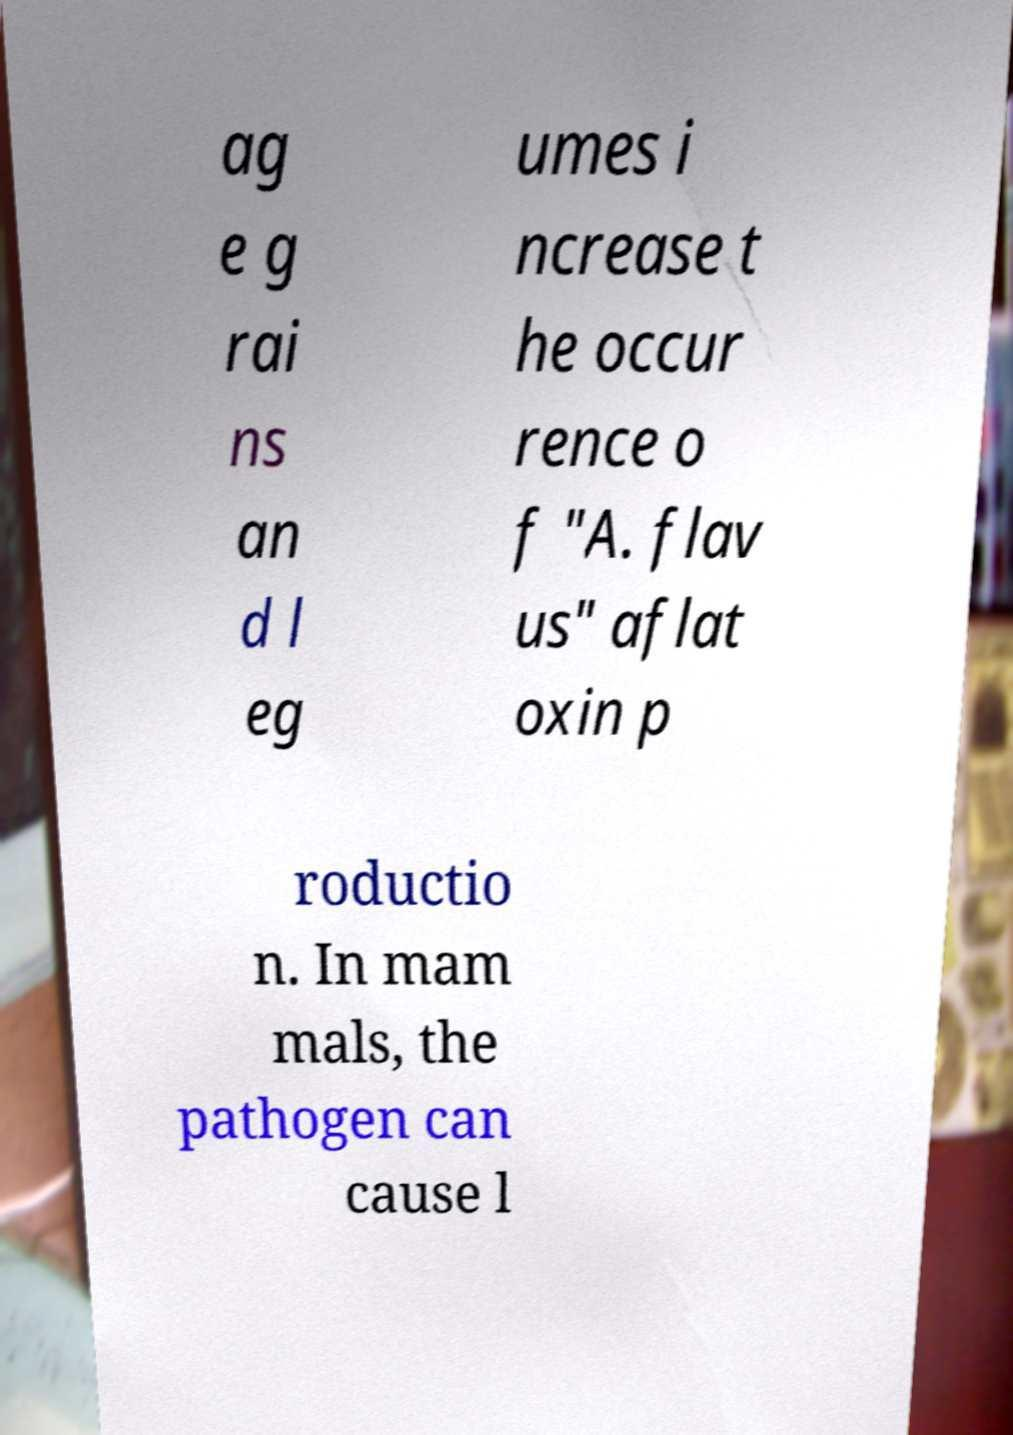I need the written content from this picture converted into text. Can you do that? ag e g rai ns an d l eg umes i ncrease t he occur rence o f "A. flav us" aflat oxin p roductio n. In mam mals, the pathogen can cause l 